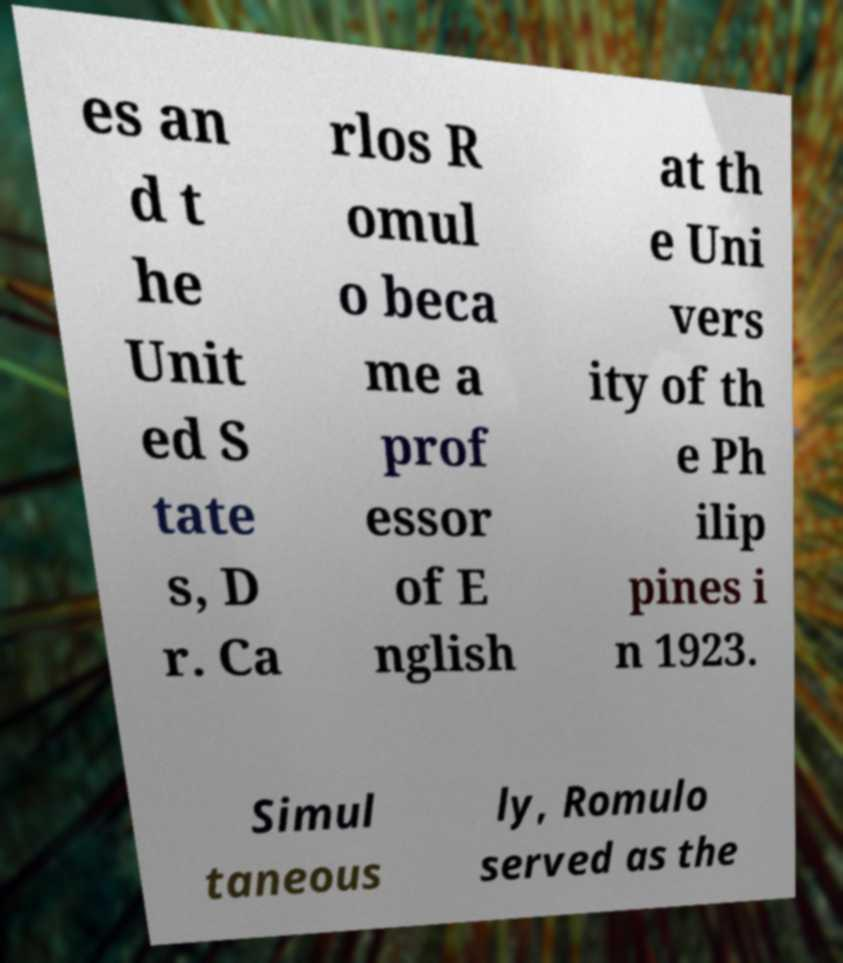Could you extract and type out the text from this image? es an d t he Unit ed S tate s, D r. Ca rlos R omul o beca me a prof essor of E nglish at th e Uni vers ity of th e Ph ilip pines i n 1923. Simul taneous ly, Romulo served as the 